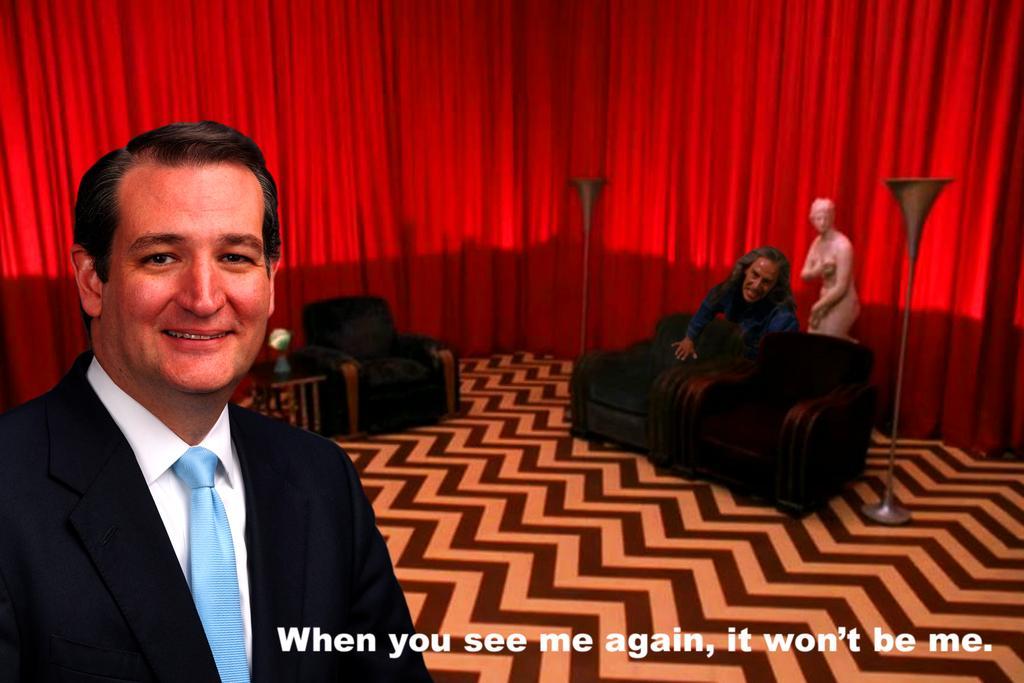Please provide a concise description of this image. In this picture we can see two persons and a statue. This is the first person and he is the second person, the first person is laughing, in the background we can find some metal rods, sofa and curtains. 